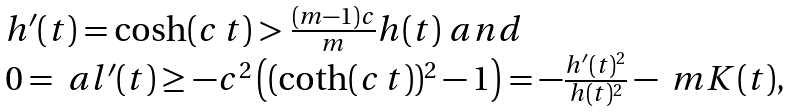Convert formula to latex. <formula><loc_0><loc_0><loc_500><loc_500>\begin{array} { l } h ^ { \prime } ( t ) = \cosh ( c \, t ) > \frac { ( m - 1 ) c } { m } h ( t ) \ a n d \\ 0 = \ a l ^ { \prime } ( t ) \geq - c ^ { 2 } \left ( ( \coth ( c \, t ) ) ^ { 2 } - 1 \right ) = - \frac { h ^ { \prime } ( t ) ^ { 2 } } { h ( t ) ^ { 2 } } - \ m K ( t ) , \end{array}</formula> 